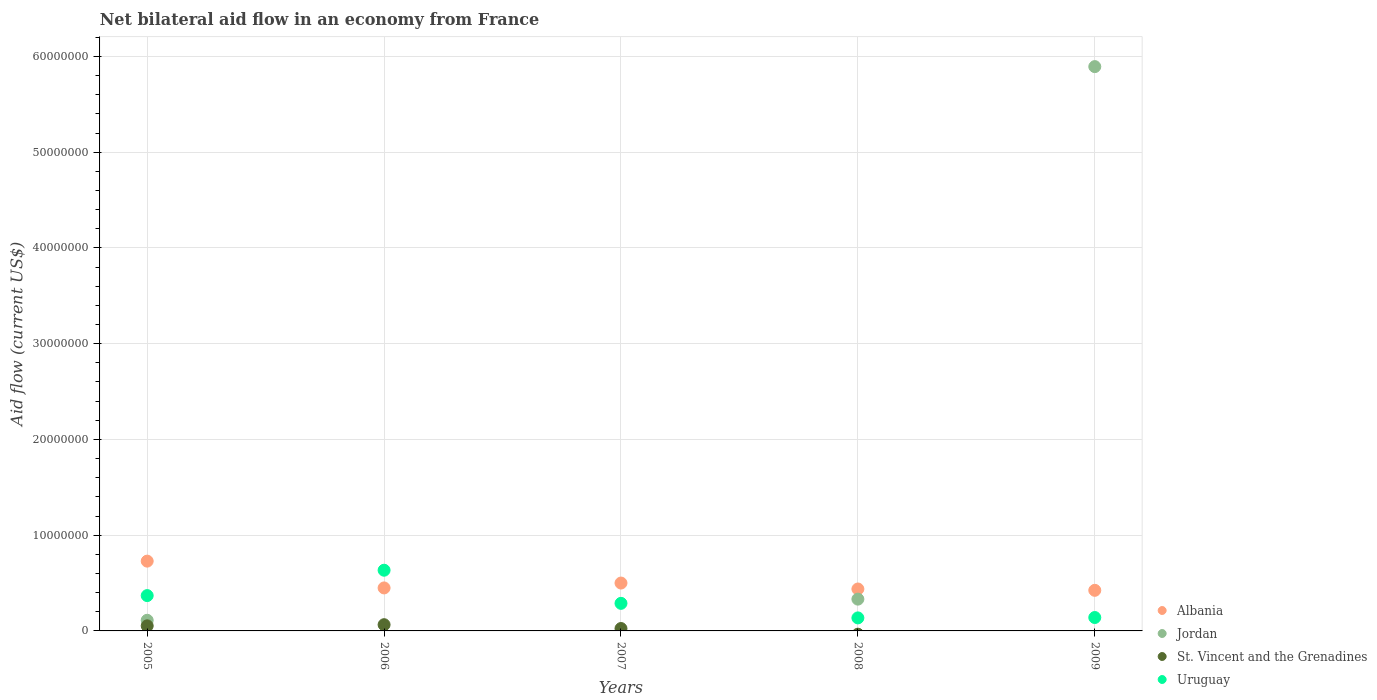Is the number of dotlines equal to the number of legend labels?
Give a very brief answer. No. What is the net bilateral aid flow in Albania in 2005?
Keep it short and to the point. 7.29e+06. Across all years, what is the maximum net bilateral aid flow in St. Vincent and the Grenadines?
Offer a terse response. 6.50e+05. Across all years, what is the minimum net bilateral aid flow in Jordan?
Your answer should be very brief. 0. What is the total net bilateral aid flow in Albania in the graph?
Keep it short and to the point. 2.54e+07. What is the difference between the net bilateral aid flow in Uruguay in 2005 and that in 2008?
Your response must be concise. 2.33e+06. What is the difference between the net bilateral aid flow in Uruguay in 2008 and the net bilateral aid flow in St. Vincent and the Grenadines in 2007?
Your response must be concise. 1.11e+06. What is the average net bilateral aid flow in St. Vincent and the Grenadines per year?
Your answer should be very brief. 2.86e+05. In the year 2007, what is the difference between the net bilateral aid flow in Albania and net bilateral aid flow in St. Vincent and the Grenadines?
Make the answer very short. 4.75e+06. In how many years, is the net bilateral aid flow in Jordan greater than 38000000 US$?
Your answer should be compact. 1. What is the ratio of the net bilateral aid flow in Jordan in 2005 to that in 2009?
Your answer should be very brief. 0.02. What is the difference between the highest and the second highest net bilateral aid flow in Albania?
Offer a terse response. 2.29e+06. What is the difference between the highest and the lowest net bilateral aid flow in Uruguay?
Provide a succinct answer. 4.98e+06. Is the sum of the net bilateral aid flow in Albania in 2008 and 2009 greater than the maximum net bilateral aid flow in St. Vincent and the Grenadines across all years?
Your answer should be very brief. Yes. Is it the case that in every year, the sum of the net bilateral aid flow in St. Vincent and the Grenadines and net bilateral aid flow in Jordan  is greater than the sum of net bilateral aid flow in Albania and net bilateral aid flow in Uruguay?
Offer a terse response. No. Does the net bilateral aid flow in St. Vincent and the Grenadines monotonically increase over the years?
Provide a short and direct response. No. Is the net bilateral aid flow in St. Vincent and the Grenadines strictly greater than the net bilateral aid flow in Jordan over the years?
Give a very brief answer. No. Is the net bilateral aid flow in Albania strictly less than the net bilateral aid flow in St. Vincent and the Grenadines over the years?
Your response must be concise. No. Are the values on the major ticks of Y-axis written in scientific E-notation?
Your answer should be compact. No. Does the graph contain any zero values?
Provide a short and direct response. Yes. Does the graph contain grids?
Offer a very short reply. Yes. How many legend labels are there?
Offer a terse response. 4. What is the title of the graph?
Offer a very short reply. Net bilateral aid flow in an economy from France. Does "Malta" appear as one of the legend labels in the graph?
Make the answer very short. No. What is the label or title of the X-axis?
Offer a terse response. Years. What is the Aid flow (current US$) of Albania in 2005?
Offer a terse response. 7.29e+06. What is the Aid flow (current US$) in Jordan in 2005?
Provide a short and direct response. 1.11e+06. What is the Aid flow (current US$) of St. Vincent and the Grenadines in 2005?
Offer a terse response. 5.30e+05. What is the Aid flow (current US$) of Uruguay in 2005?
Give a very brief answer. 3.69e+06. What is the Aid flow (current US$) of Albania in 2006?
Provide a succinct answer. 4.49e+06. What is the Aid flow (current US$) in St. Vincent and the Grenadines in 2006?
Provide a succinct answer. 6.50e+05. What is the Aid flow (current US$) in Uruguay in 2006?
Your answer should be very brief. 6.34e+06. What is the Aid flow (current US$) of Albania in 2007?
Provide a succinct answer. 5.00e+06. What is the Aid flow (current US$) of Uruguay in 2007?
Give a very brief answer. 2.88e+06. What is the Aid flow (current US$) in Albania in 2008?
Provide a succinct answer. 4.38e+06. What is the Aid flow (current US$) of Jordan in 2008?
Your answer should be compact. 3.32e+06. What is the Aid flow (current US$) in Uruguay in 2008?
Ensure brevity in your answer.  1.36e+06. What is the Aid flow (current US$) of Albania in 2009?
Provide a succinct answer. 4.24e+06. What is the Aid flow (current US$) of Jordan in 2009?
Provide a short and direct response. 5.89e+07. What is the Aid flow (current US$) of St. Vincent and the Grenadines in 2009?
Make the answer very short. 0. What is the Aid flow (current US$) of Uruguay in 2009?
Give a very brief answer. 1.40e+06. Across all years, what is the maximum Aid flow (current US$) in Albania?
Your answer should be very brief. 7.29e+06. Across all years, what is the maximum Aid flow (current US$) in Jordan?
Your answer should be very brief. 5.89e+07. Across all years, what is the maximum Aid flow (current US$) of St. Vincent and the Grenadines?
Offer a very short reply. 6.50e+05. Across all years, what is the maximum Aid flow (current US$) of Uruguay?
Your answer should be very brief. 6.34e+06. Across all years, what is the minimum Aid flow (current US$) in Albania?
Your response must be concise. 4.24e+06. Across all years, what is the minimum Aid flow (current US$) in Uruguay?
Keep it short and to the point. 1.36e+06. What is the total Aid flow (current US$) of Albania in the graph?
Your answer should be compact. 2.54e+07. What is the total Aid flow (current US$) in Jordan in the graph?
Provide a short and direct response. 6.34e+07. What is the total Aid flow (current US$) of St. Vincent and the Grenadines in the graph?
Ensure brevity in your answer.  1.43e+06. What is the total Aid flow (current US$) in Uruguay in the graph?
Your answer should be very brief. 1.57e+07. What is the difference between the Aid flow (current US$) of Albania in 2005 and that in 2006?
Make the answer very short. 2.80e+06. What is the difference between the Aid flow (current US$) in Uruguay in 2005 and that in 2006?
Offer a very short reply. -2.65e+06. What is the difference between the Aid flow (current US$) of Albania in 2005 and that in 2007?
Give a very brief answer. 2.29e+06. What is the difference between the Aid flow (current US$) in St. Vincent and the Grenadines in 2005 and that in 2007?
Keep it short and to the point. 2.80e+05. What is the difference between the Aid flow (current US$) of Uruguay in 2005 and that in 2007?
Offer a terse response. 8.10e+05. What is the difference between the Aid flow (current US$) of Albania in 2005 and that in 2008?
Offer a terse response. 2.91e+06. What is the difference between the Aid flow (current US$) of Jordan in 2005 and that in 2008?
Give a very brief answer. -2.21e+06. What is the difference between the Aid flow (current US$) in Uruguay in 2005 and that in 2008?
Give a very brief answer. 2.33e+06. What is the difference between the Aid flow (current US$) in Albania in 2005 and that in 2009?
Your answer should be compact. 3.05e+06. What is the difference between the Aid flow (current US$) of Jordan in 2005 and that in 2009?
Keep it short and to the point. -5.78e+07. What is the difference between the Aid flow (current US$) of Uruguay in 2005 and that in 2009?
Offer a terse response. 2.29e+06. What is the difference between the Aid flow (current US$) in Albania in 2006 and that in 2007?
Your answer should be very brief. -5.10e+05. What is the difference between the Aid flow (current US$) of Uruguay in 2006 and that in 2007?
Provide a short and direct response. 3.46e+06. What is the difference between the Aid flow (current US$) of Uruguay in 2006 and that in 2008?
Provide a short and direct response. 4.98e+06. What is the difference between the Aid flow (current US$) in Albania in 2006 and that in 2009?
Your answer should be very brief. 2.50e+05. What is the difference between the Aid flow (current US$) of Uruguay in 2006 and that in 2009?
Ensure brevity in your answer.  4.94e+06. What is the difference between the Aid flow (current US$) in Albania in 2007 and that in 2008?
Offer a terse response. 6.20e+05. What is the difference between the Aid flow (current US$) in Uruguay in 2007 and that in 2008?
Provide a succinct answer. 1.52e+06. What is the difference between the Aid flow (current US$) in Albania in 2007 and that in 2009?
Your answer should be very brief. 7.60e+05. What is the difference between the Aid flow (current US$) of Uruguay in 2007 and that in 2009?
Keep it short and to the point. 1.48e+06. What is the difference between the Aid flow (current US$) of Jordan in 2008 and that in 2009?
Offer a very short reply. -5.56e+07. What is the difference between the Aid flow (current US$) in Albania in 2005 and the Aid flow (current US$) in St. Vincent and the Grenadines in 2006?
Provide a short and direct response. 6.64e+06. What is the difference between the Aid flow (current US$) of Albania in 2005 and the Aid flow (current US$) of Uruguay in 2006?
Your answer should be compact. 9.50e+05. What is the difference between the Aid flow (current US$) in Jordan in 2005 and the Aid flow (current US$) in St. Vincent and the Grenadines in 2006?
Make the answer very short. 4.60e+05. What is the difference between the Aid flow (current US$) of Jordan in 2005 and the Aid flow (current US$) of Uruguay in 2006?
Your answer should be compact. -5.23e+06. What is the difference between the Aid flow (current US$) of St. Vincent and the Grenadines in 2005 and the Aid flow (current US$) of Uruguay in 2006?
Your answer should be compact. -5.81e+06. What is the difference between the Aid flow (current US$) of Albania in 2005 and the Aid flow (current US$) of St. Vincent and the Grenadines in 2007?
Your answer should be compact. 7.04e+06. What is the difference between the Aid flow (current US$) of Albania in 2005 and the Aid flow (current US$) of Uruguay in 2007?
Keep it short and to the point. 4.41e+06. What is the difference between the Aid flow (current US$) of Jordan in 2005 and the Aid flow (current US$) of St. Vincent and the Grenadines in 2007?
Keep it short and to the point. 8.60e+05. What is the difference between the Aid flow (current US$) in Jordan in 2005 and the Aid flow (current US$) in Uruguay in 2007?
Your answer should be very brief. -1.77e+06. What is the difference between the Aid flow (current US$) in St. Vincent and the Grenadines in 2005 and the Aid flow (current US$) in Uruguay in 2007?
Provide a succinct answer. -2.35e+06. What is the difference between the Aid flow (current US$) in Albania in 2005 and the Aid flow (current US$) in Jordan in 2008?
Offer a very short reply. 3.97e+06. What is the difference between the Aid flow (current US$) in Albania in 2005 and the Aid flow (current US$) in Uruguay in 2008?
Keep it short and to the point. 5.93e+06. What is the difference between the Aid flow (current US$) in St. Vincent and the Grenadines in 2005 and the Aid flow (current US$) in Uruguay in 2008?
Provide a short and direct response. -8.30e+05. What is the difference between the Aid flow (current US$) in Albania in 2005 and the Aid flow (current US$) in Jordan in 2009?
Offer a very short reply. -5.16e+07. What is the difference between the Aid flow (current US$) of Albania in 2005 and the Aid flow (current US$) of Uruguay in 2009?
Give a very brief answer. 5.89e+06. What is the difference between the Aid flow (current US$) in Jordan in 2005 and the Aid flow (current US$) in Uruguay in 2009?
Make the answer very short. -2.90e+05. What is the difference between the Aid flow (current US$) of St. Vincent and the Grenadines in 2005 and the Aid flow (current US$) of Uruguay in 2009?
Provide a short and direct response. -8.70e+05. What is the difference between the Aid flow (current US$) of Albania in 2006 and the Aid flow (current US$) of St. Vincent and the Grenadines in 2007?
Your answer should be very brief. 4.24e+06. What is the difference between the Aid flow (current US$) in Albania in 2006 and the Aid flow (current US$) in Uruguay in 2007?
Your answer should be compact. 1.61e+06. What is the difference between the Aid flow (current US$) in St. Vincent and the Grenadines in 2006 and the Aid flow (current US$) in Uruguay in 2007?
Make the answer very short. -2.23e+06. What is the difference between the Aid flow (current US$) of Albania in 2006 and the Aid flow (current US$) of Jordan in 2008?
Offer a terse response. 1.17e+06. What is the difference between the Aid flow (current US$) of Albania in 2006 and the Aid flow (current US$) of Uruguay in 2008?
Your response must be concise. 3.13e+06. What is the difference between the Aid flow (current US$) in St. Vincent and the Grenadines in 2006 and the Aid flow (current US$) in Uruguay in 2008?
Offer a terse response. -7.10e+05. What is the difference between the Aid flow (current US$) of Albania in 2006 and the Aid flow (current US$) of Jordan in 2009?
Your answer should be very brief. -5.44e+07. What is the difference between the Aid flow (current US$) in Albania in 2006 and the Aid flow (current US$) in Uruguay in 2009?
Your response must be concise. 3.09e+06. What is the difference between the Aid flow (current US$) of St. Vincent and the Grenadines in 2006 and the Aid flow (current US$) of Uruguay in 2009?
Give a very brief answer. -7.50e+05. What is the difference between the Aid flow (current US$) in Albania in 2007 and the Aid flow (current US$) in Jordan in 2008?
Keep it short and to the point. 1.68e+06. What is the difference between the Aid flow (current US$) of Albania in 2007 and the Aid flow (current US$) of Uruguay in 2008?
Ensure brevity in your answer.  3.64e+06. What is the difference between the Aid flow (current US$) in St. Vincent and the Grenadines in 2007 and the Aid flow (current US$) in Uruguay in 2008?
Offer a terse response. -1.11e+06. What is the difference between the Aid flow (current US$) in Albania in 2007 and the Aid flow (current US$) in Jordan in 2009?
Offer a very short reply. -5.39e+07. What is the difference between the Aid flow (current US$) of Albania in 2007 and the Aid flow (current US$) of Uruguay in 2009?
Provide a succinct answer. 3.60e+06. What is the difference between the Aid flow (current US$) in St. Vincent and the Grenadines in 2007 and the Aid flow (current US$) in Uruguay in 2009?
Your response must be concise. -1.15e+06. What is the difference between the Aid flow (current US$) of Albania in 2008 and the Aid flow (current US$) of Jordan in 2009?
Offer a terse response. -5.46e+07. What is the difference between the Aid flow (current US$) in Albania in 2008 and the Aid flow (current US$) in Uruguay in 2009?
Provide a succinct answer. 2.98e+06. What is the difference between the Aid flow (current US$) of Jordan in 2008 and the Aid flow (current US$) of Uruguay in 2009?
Give a very brief answer. 1.92e+06. What is the average Aid flow (current US$) of Albania per year?
Your response must be concise. 5.08e+06. What is the average Aid flow (current US$) of Jordan per year?
Your response must be concise. 1.27e+07. What is the average Aid flow (current US$) of St. Vincent and the Grenadines per year?
Ensure brevity in your answer.  2.86e+05. What is the average Aid flow (current US$) of Uruguay per year?
Make the answer very short. 3.13e+06. In the year 2005, what is the difference between the Aid flow (current US$) of Albania and Aid flow (current US$) of Jordan?
Provide a succinct answer. 6.18e+06. In the year 2005, what is the difference between the Aid flow (current US$) in Albania and Aid flow (current US$) in St. Vincent and the Grenadines?
Ensure brevity in your answer.  6.76e+06. In the year 2005, what is the difference between the Aid flow (current US$) in Albania and Aid flow (current US$) in Uruguay?
Offer a very short reply. 3.60e+06. In the year 2005, what is the difference between the Aid flow (current US$) of Jordan and Aid flow (current US$) of St. Vincent and the Grenadines?
Offer a terse response. 5.80e+05. In the year 2005, what is the difference between the Aid flow (current US$) in Jordan and Aid flow (current US$) in Uruguay?
Provide a succinct answer. -2.58e+06. In the year 2005, what is the difference between the Aid flow (current US$) in St. Vincent and the Grenadines and Aid flow (current US$) in Uruguay?
Your response must be concise. -3.16e+06. In the year 2006, what is the difference between the Aid flow (current US$) in Albania and Aid flow (current US$) in St. Vincent and the Grenadines?
Provide a succinct answer. 3.84e+06. In the year 2006, what is the difference between the Aid flow (current US$) of Albania and Aid flow (current US$) of Uruguay?
Provide a succinct answer. -1.85e+06. In the year 2006, what is the difference between the Aid flow (current US$) in St. Vincent and the Grenadines and Aid flow (current US$) in Uruguay?
Offer a terse response. -5.69e+06. In the year 2007, what is the difference between the Aid flow (current US$) of Albania and Aid flow (current US$) of St. Vincent and the Grenadines?
Offer a terse response. 4.75e+06. In the year 2007, what is the difference between the Aid flow (current US$) in Albania and Aid flow (current US$) in Uruguay?
Give a very brief answer. 2.12e+06. In the year 2007, what is the difference between the Aid flow (current US$) in St. Vincent and the Grenadines and Aid flow (current US$) in Uruguay?
Your response must be concise. -2.63e+06. In the year 2008, what is the difference between the Aid flow (current US$) in Albania and Aid flow (current US$) in Jordan?
Provide a succinct answer. 1.06e+06. In the year 2008, what is the difference between the Aid flow (current US$) in Albania and Aid flow (current US$) in Uruguay?
Ensure brevity in your answer.  3.02e+06. In the year 2008, what is the difference between the Aid flow (current US$) in Jordan and Aid flow (current US$) in Uruguay?
Provide a succinct answer. 1.96e+06. In the year 2009, what is the difference between the Aid flow (current US$) of Albania and Aid flow (current US$) of Jordan?
Give a very brief answer. -5.47e+07. In the year 2009, what is the difference between the Aid flow (current US$) of Albania and Aid flow (current US$) of Uruguay?
Your answer should be compact. 2.84e+06. In the year 2009, what is the difference between the Aid flow (current US$) of Jordan and Aid flow (current US$) of Uruguay?
Your answer should be compact. 5.75e+07. What is the ratio of the Aid flow (current US$) in Albania in 2005 to that in 2006?
Ensure brevity in your answer.  1.62. What is the ratio of the Aid flow (current US$) of St. Vincent and the Grenadines in 2005 to that in 2006?
Your answer should be compact. 0.82. What is the ratio of the Aid flow (current US$) in Uruguay in 2005 to that in 2006?
Provide a short and direct response. 0.58. What is the ratio of the Aid flow (current US$) in Albania in 2005 to that in 2007?
Offer a terse response. 1.46. What is the ratio of the Aid flow (current US$) in St. Vincent and the Grenadines in 2005 to that in 2007?
Keep it short and to the point. 2.12. What is the ratio of the Aid flow (current US$) of Uruguay in 2005 to that in 2007?
Your response must be concise. 1.28. What is the ratio of the Aid flow (current US$) in Albania in 2005 to that in 2008?
Ensure brevity in your answer.  1.66. What is the ratio of the Aid flow (current US$) of Jordan in 2005 to that in 2008?
Provide a succinct answer. 0.33. What is the ratio of the Aid flow (current US$) in Uruguay in 2005 to that in 2008?
Give a very brief answer. 2.71. What is the ratio of the Aid flow (current US$) in Albania in 2005 to that in 2009?
Your response must be concise. 1.72. What is the ratio of the Aid flow (current US$) in Jordan in 2005 to that in 2009?
Your response must be concise. 0.02. What is the ratio of the Aid flow (current US$) of Uruguay in 2005 to that in 2009?
Make the answer very short. 2.64. What is the ratio of the Aid flow (current US$) in Albania in 2006 to that in 2007?
Your response must be concise. 0.9. What is the ratio of the Aid flow (current US$) in St. Vincent and the Grenadines in 2006 to that in 2007?
Make the answer very short. 2.6. What is the ratio of the Aid flow (current US$) of Uruguay in 2006 to that in 2007?
Make the answer very short. 2.2. What is the ratio of the Aid flow (current US$) of Albania in 2006 to that in 2008?
Keep it short and to the point. 1.03. What is the ratio of the Aid flow (current US$) in Uruguay in 2006 to that in 2008?
Your answer should be very brief. 4.66. What is the ratio of the Aid flow (current US$) in Albania in 2006 to that in 2009?
Ensure brevity in your answer.  1.06. What is the ratio of the Aid flow (current US$) of Uruguay in 2006 to that in 2009?
Give a very brief answer. 4.53. What is the ratio of the Aid flow (current US$) in Albania in 2007 to that in 2008?
Provide a short and direct response. 1.14. What is the ratio of the Aid flow (current US$) in Uruguay in 2007 to that in 2008?
Your answer should be compact. 2.12. What is the ratio of the Aid flow (current US$) of Albania in 2007 to that in 2009?
Your response must be concise. 1.18. What is the ratio of the Aid flow (current US$) in Uruguay in 2007 to that in 2009?
Ensure brevity in your answer.  2.06. What is the ratio of the Aid flow (current US$) of Albania in 2008 to that in 2009?
Ensure brevity in your answer.  1.03. What is the ratio of the Aid flow (current US$) in Jordan in 2008 to that in 2009?
Offer a very short reply. 0.06. What is the ratio of the Aid flow (current US$) in Uruguay in 2008 to that in 2009?
Your answer should be compact. 0.97. What is the difference between the highest and the second highest Aid flow (current US$) in Albania?
Provide a short and direct response. 2.29e+06. What is the difference between the highest and the second highest Aid flow (current US$) of Jordan?
Ensure brevity in your answer.  5.56e+07. What is the difference between the highest and the second highest Aid flow (current US$) of Uruguay?
Your response must be concise. 2.65e+06. What is the difference between the highest and the lowest Aid flow (current US$) in Albania?
Ensure brevity in your answer.  3.05e+06. What is the difference between the highest and the lowest Aid flow (current US$) in Jordan?
Provide a succinct answer. 5.89e+07. What is the difference between the highest and the lowest Aid flow (current US$) of St. Vincent and the Grenadines?
Give a very brief answer. 6.50e+05. What is the difference between the highest and the lowest Aid flow (current US$) in Uruguay?
Ensure brevity in your answer.  4.98e+06. 